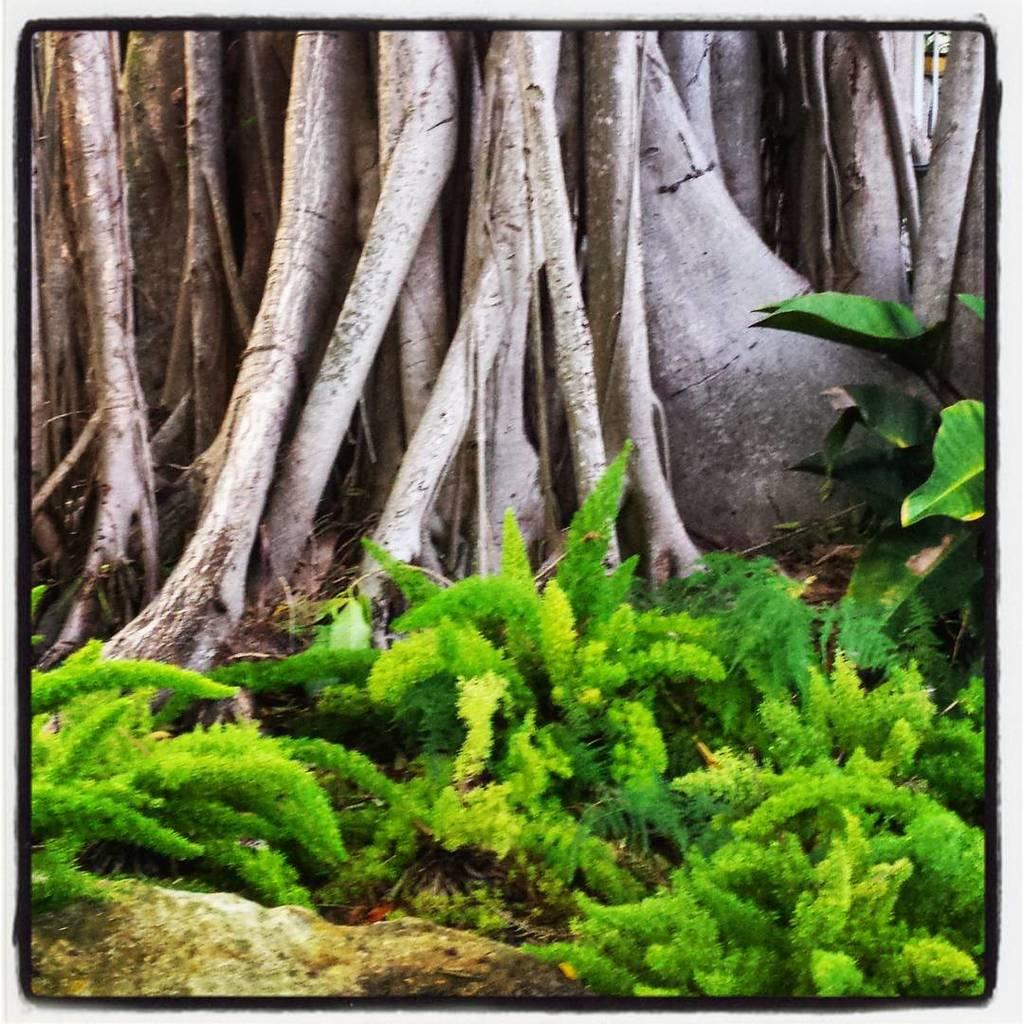What type of vegetation can be seen in the image? There are trees and plants grown on the ground in the image. Can you describe the plants in the image? The plants grown on the ground are not specified, but they are visible in the image. Where is the hospital located in the image? There is no hospital present in the image. Can you tell me how many pigs are sleeping in the image}? There are no pigs or any sleeping animals present in the image. 